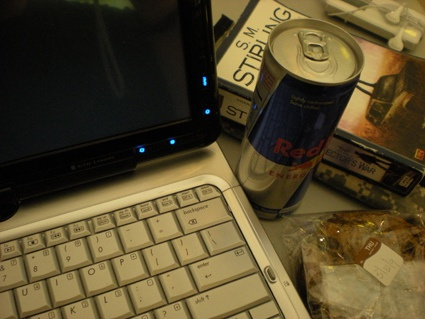Describe the objects in this image and their specific colors. I can see laptop in black, tan, and olive tones and book in black, tan, maroon, and olive tones in this image. 